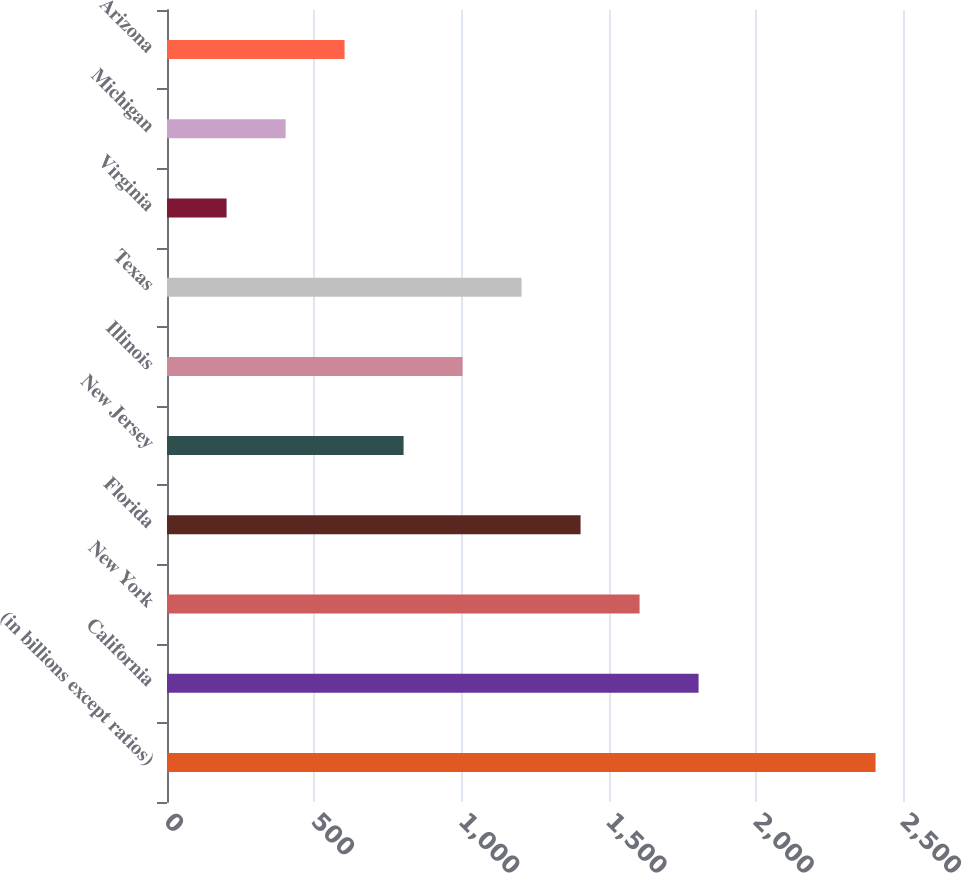Convert chart. <chart><loc_0><loc_0><loc_500><loc_500><bar_chart><fcel>(in billions except ratios)<fcel>California<fcel>New York<fcel>Florida<fcel>New Jersey<fcel>Illinois<fcel>Texas<fcel>Virginia<fcel>Michigan<fcel>Arizona<nl><fcel>2406.8<fcel>1805.6<fcel>1605.2<fcel>1404.8<fcel>803.6<fcel>1004<fcel>1204.4<fcel>202.4<fcel>402.8<fcel>603.2<nl></chart> 